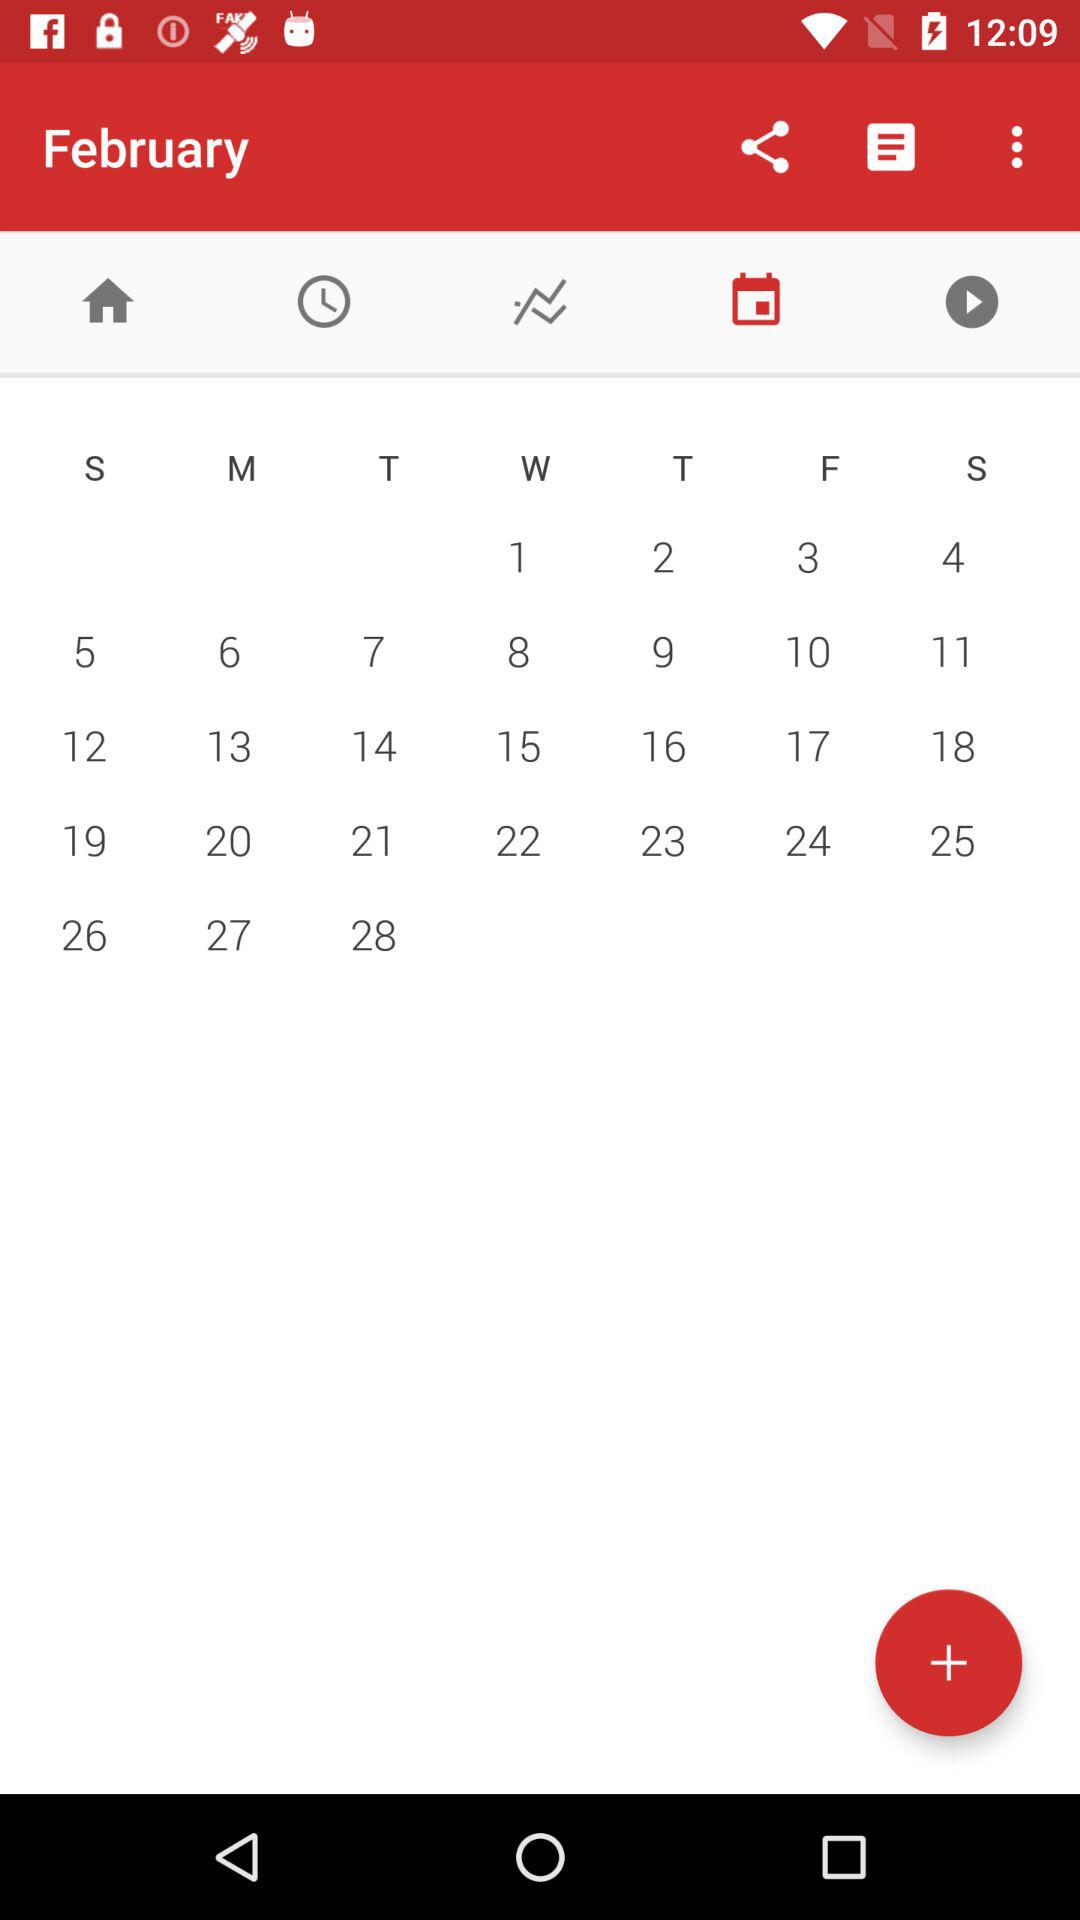What month is given in the calendar? The month given is "February". 